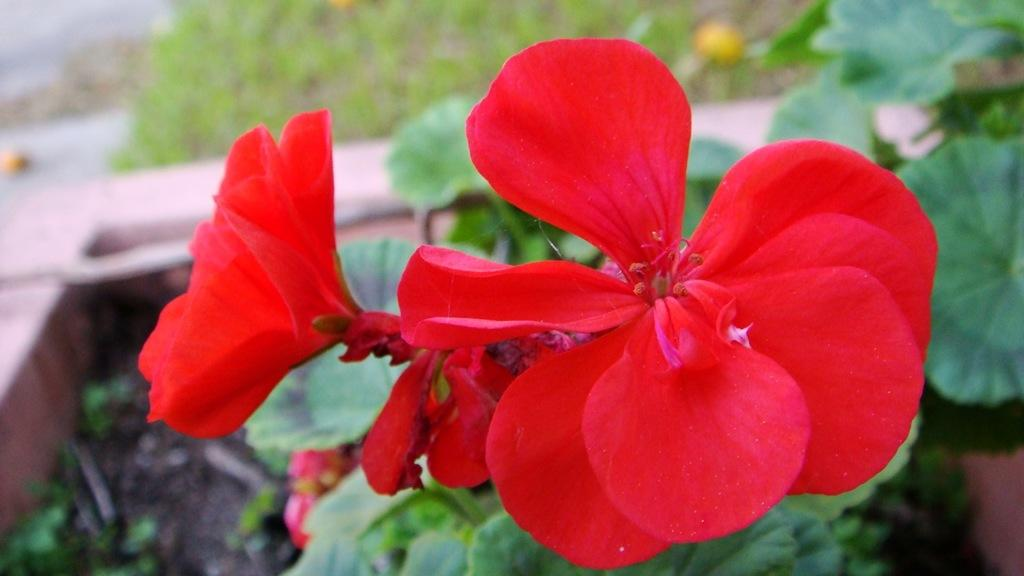What is present in the image? There are flowers in the image. Where are the flowers located? The flowers are on plants. Can you describe the background of the image? There is a blurred image of plants in the background. What type of leather can be seen covering the ants in the image? There are no ants or leather present in the image; it only features flowers on plants. 